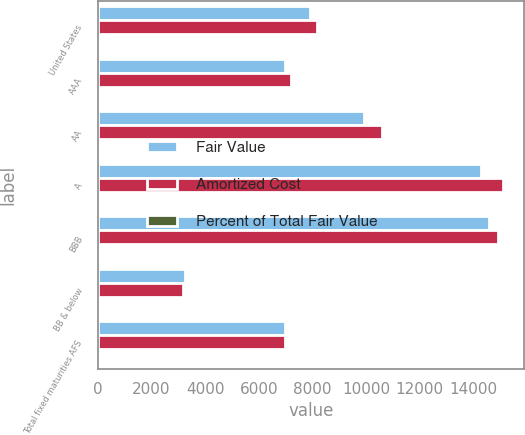Convert chart. <chart><loc_0><loc_0><loc_500><loc_500><stacked_bar_chart><ecel><fcel>United States<fcel>AAA<fcel>AA<fcel>A<fcel>BBB<fcel>BB & below<fcel>Total fixed maturities AFS<nl><fcel>Fair Value<fcel>7911<fcel>6980<fcel>9943<fcel>14297<fcel>14598<fcel>3236<fcel>6980<nl><fcel>Amortized Cost<fcel>8179<fcel>7195<fcel>10584<fcel>15128<fcel>14918<fcel>3192<fcel>6980<nl><fcel>Percent of Total Fair Value<fcel>13.8<fcel>12.2<fcel>17.9<fcel>25.5<fcel>25.2<fcel>5.4<fcel>100<nl></chart> 